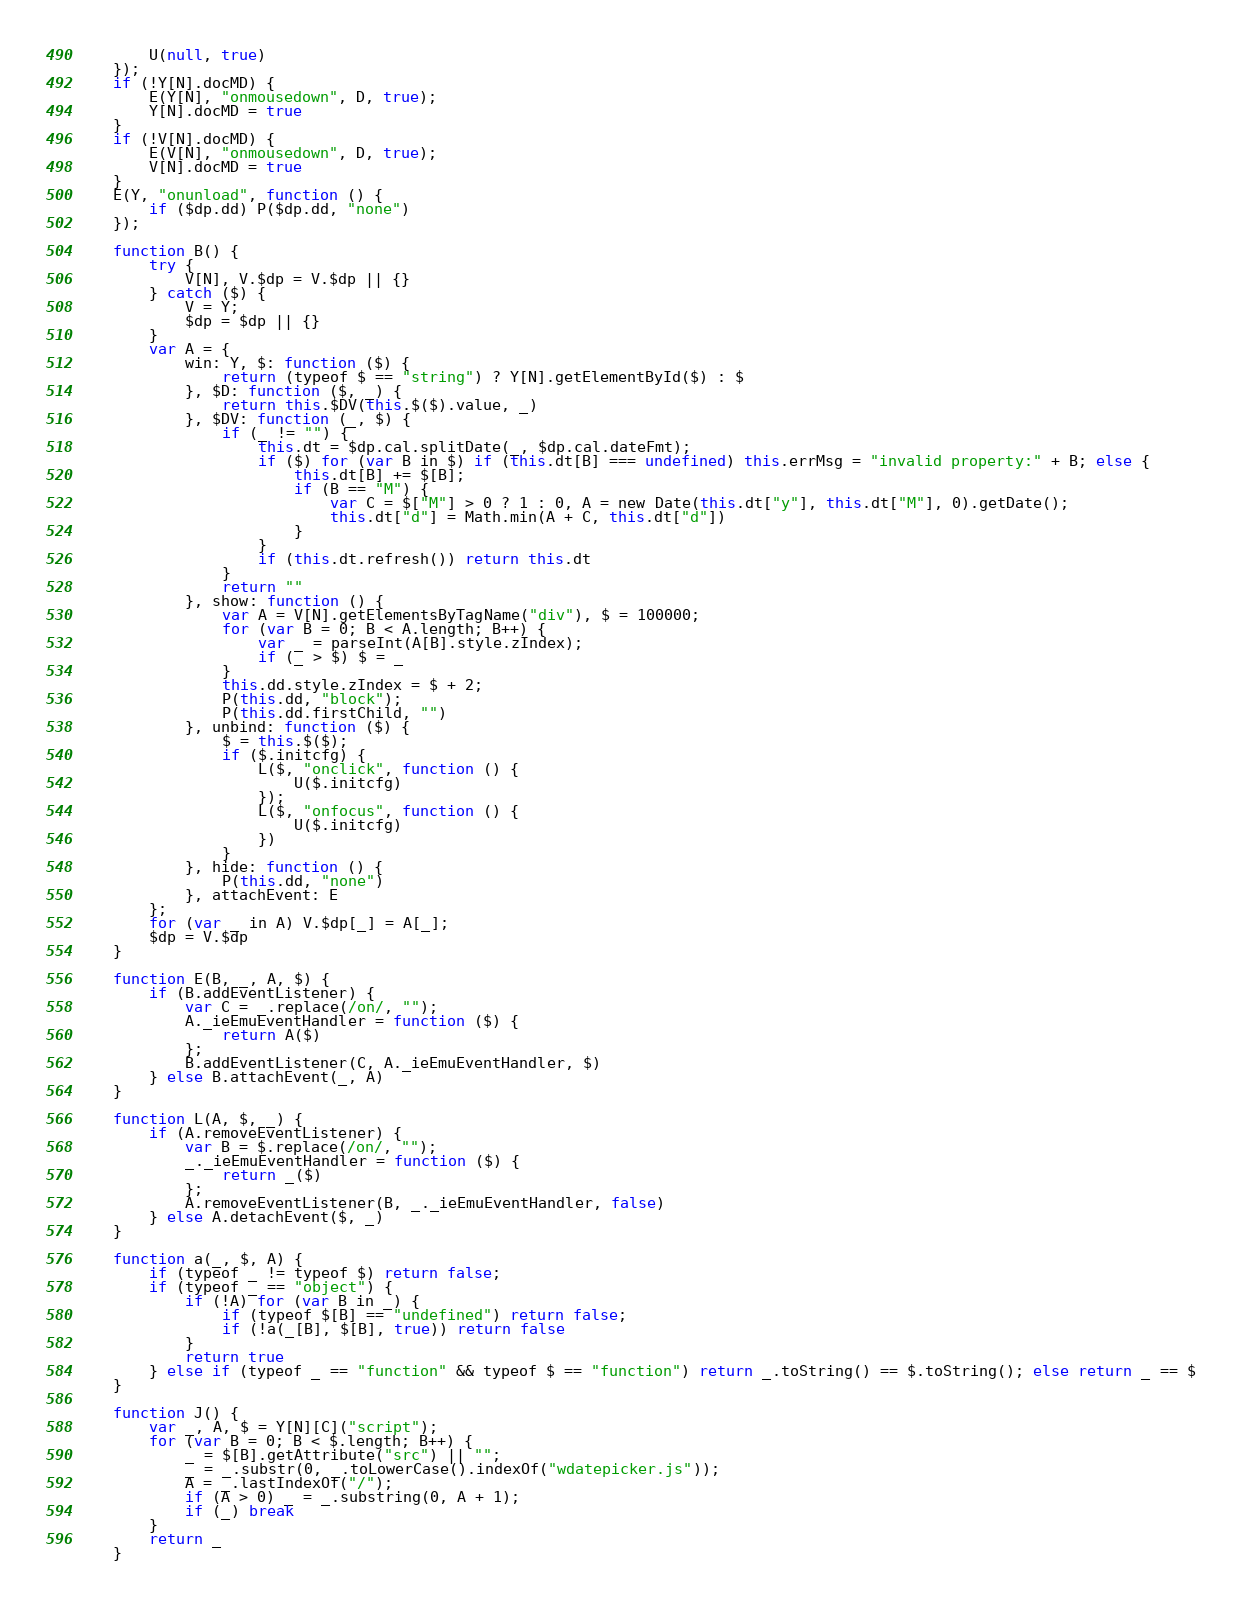<code> <loc_0><loc_0><loc_500><loc_500><_JavaScript_>        U(null, true)
    });
    if (!Y[N].docMD) {
        E(Y[N], "onmousedown", D, true);
        Y[N].docMD = true
    }
    if (!V[N].docMD) {
        E(V[N], "onmousedown", D, true);
        V[N].docMD = true
    }
    E(Y, "onunload", function () {
        if ($dp.dd) P($dp.dd, "none")
    });

    function B() {
        try {
            V[N], V.$dp = V.$dp || {}
        } catch ($) {
            V = Y;
            $dp = $dp || {}
        }
        var A = {
            win: Y, $: function ($) {
                return (typeof $ == "string") ? Y[N].getElementById($) : $
            }, $D: function ($, _) {
                return this.$DV(this.$($).value, _)
            }, $DV: function (_, $) {
                if (_ != "") {
                    this.dt = $dp.cal.splitDate(_, $dp.cal.dateFmt);
                    if ($) for (var B in $) if (this.dt[B] === undefined) this.errMsg = "invalid property:" + B; else {
                        this.dt[B] += $[B];
                        if (B == "M") {
                            var C = $["M"] > 0 ? 1 : 0, A = new Date(this.dt["y"], this.dt["M"], 0).getDate();
                            this.dt["d"] = Math.min(A + C, this.dt["d"])
                        }
                    }
                    if (this.dt.refresh()) return this.dt
                }
                return ""
            }, show: function () {
                var A = V[N].getElementsByTagName("div"), $ = 100000;
                for (var B = 0; B < A.length; B++) {
                    var _ = parseInt(A[B].style.zIndex);
                    if (_ > $) $ = _
                }
                this.dd.style.zIndex = $ + 2;
                P(this.dd, "block");
                P(this.dd.firstChild, "")
            }, unbind: function ($) {
                $ = this.$($);
                if ($.initcfg) {
                    L($, "onclick", function () {
                        U($.initcfg)
                    });
                    L($, "onfocus", function () {
                        U($.initcfg)
                    })
                }
            }, hide: function () {
                P(this.dd, "none")
            }, attachEvent: E
        };
        for (var _ in A) V.$dp[_] = A[_];
        $dp = V.$dp
    }

    function E(B, _, A, $) {
        if (B.addEventListener) {
            var C = _.replace(/on/, "");
            A._ieEmuEventHandler = function ($) {
                return A($)
            };
            B.addEventListener(C, A._ieEmuEventHandler, $)
        } else B.attachEvent(_, A)
    }

    function L(A, $, _) {
        if (A.removeEventListener) {
            var B = $.replace(/on/, "");
            _._ieEmuEventHandler = function ($) {
                return _($)
            };
            A.removeEventListener(B, _._ieEmuEventHandler, false)
        } else A.detachEvent($, _)
    }

    function a(_, $, A) {
        if (typeof _ != typeof $) return false;
        if (typeof _ == "object") {
            if (!A) for (var B in _) {
                if (typeof $[B] == "undefined") return false;
                if (!a(_[B], $[B], true)) return false
            }
            return true
        } else if (typeof _ == "function" && typeof $ == "function") return _.toString() == $.toString(); else return _ == $
    }

    function J() {
        var _, A, $ = Y[N][C]("script");
        for (var B = 0; B < $.length; B++) {
            _ = $[B].getAttribute("src") || "";
            _ = _.substr(0, _.toLowerCase().indexOf("wdatepicker.js"));
            A = _.lastIndexOf("/");
            if (A > 0) _ = _.substring(0, A + 1);
            if (_) break
        }
        return _
    }
</code> 